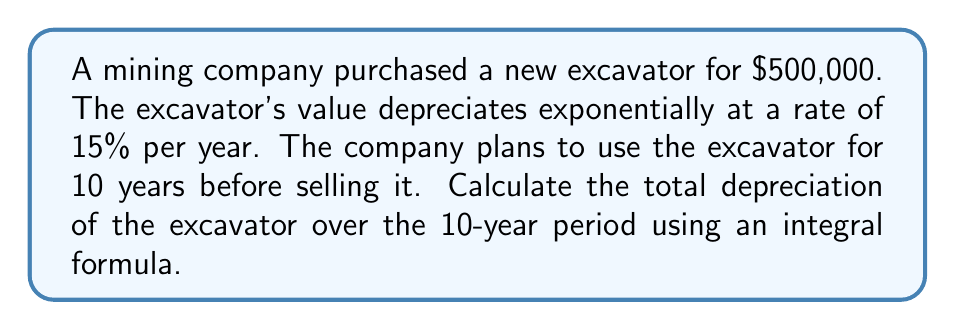Help me with this question. To solve this problem, we'll follow these steps:

1) Let $V(t)$ be the value of the excavator at time $t$ (in years). The initial value is $V(0) = 500,000$.

2) Given the exponential depreciation rate of 15% per year, we can model the value as:

   $V(t) = 500,000 \cdot e^{-0.15t}$

3) The depreciation over the 10-year period is the difference between the initial value and the final value:

   $D = V(0) - V(10) = 500,000 - 500,000 \cdot e^{-0.15 \cdot 10}$

4) However, to use an integral formula, we need to consider the rate of change of the value over time:

   $\frac{dV}{dt} = -75,000 \cdot e^{-0.15t}$

5) The total depreciation can be calculated by integrating this rate over the 10-year period:

   $D = \int_0^{10} -\frac{dV}{dt} dt = \int_0^{10} 75,000 \cdot e^{-0.15t} dt$

6) Evaluating this integral:

   $D = -500,000 \cdot e^{-0.15t} \Big|_0^{10}$
   $= -500,000 \cdot (e^{-0.15 \cdot 10} - e^{-0.15 \cdot 0})$
   $= -500,000 \cdot (e^{-1.5} - 1)$
   $= 500,000 \cdot (1 - e^{-1.5})$
   $\approx 388,863.45$

Therefore, the total depreciation over the 10-year period is approximately $388,863.45.
Answer: $500,000 \cdot (1 - e^{-1.5}) \approx $388,863.45 